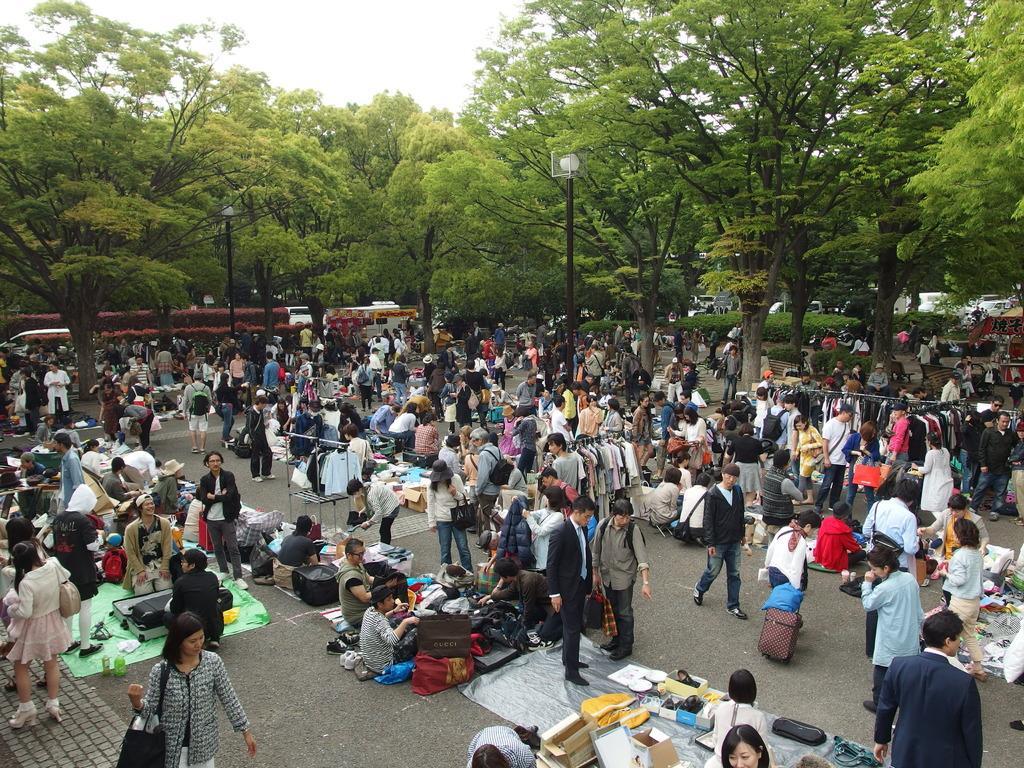Describe this image in one or two sentences. In this image there are group of people standing on the ground, While some people are sitting on the floor and selling the things. In the background there are trees. At the top there is the sky. It looks like a market. 